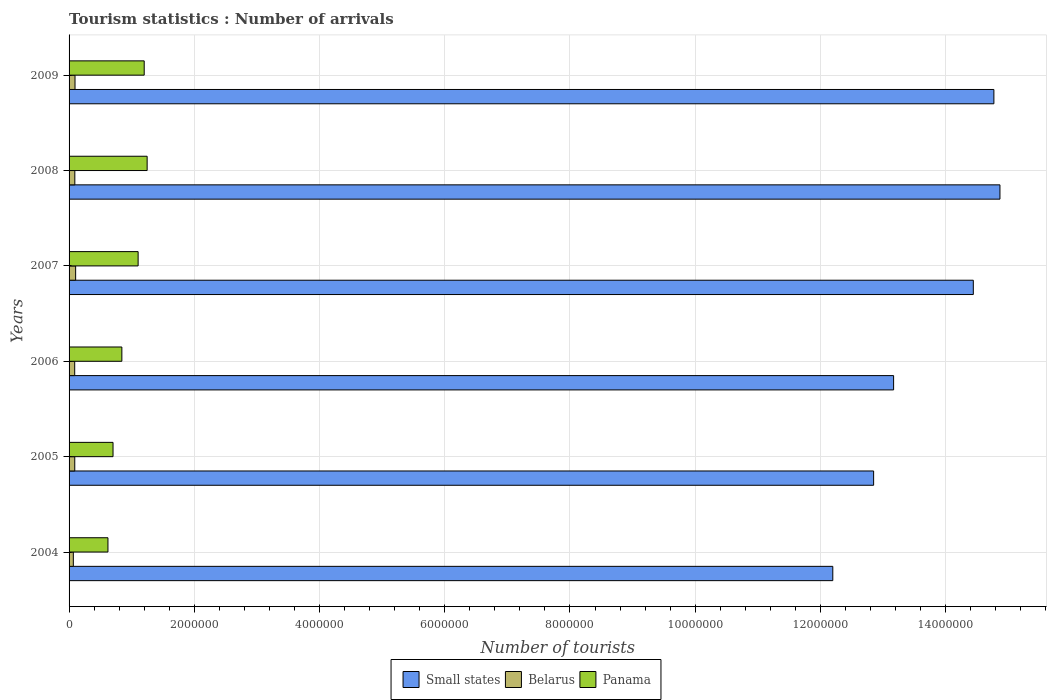What is the number of tourist arrivals in Belarus in 2006?
Your response must be concise. 9.00e+04. Across all years, what is the maximum number of tourist arrivals in Belarus?
Provide a succinct answer. 1.05e+05. Across all years, what is the minimum number of tourist arrivals in Belarus?
Offer a terse response. 6.80e+04. In which year was the number of tourist arrivals in Small states minimum?
Your answer should be very brief. 2004. What is the total number of tourist arrivals in Panama in the graph?
Ensure brevity in your answer.  5.72e+06. What is the difference between the number of tourist arrivals in Belarus in 2007 and that in 2008?
Keep it short and to the point. 1.30e+04. What is the difference between the number of tourist arrivals in Small states in 2005 and the number of tourist arrivals in Panama in 2009?
Ensure brevity in your answer.  1.16e+07. What is the average number of tourist arrivals in Belarus per year?
Provide a succinct answer. 9.02e+04. In the year 2005, what is the difference between the number of tourist arrivals in Belarus and number of tourist arrivals in Panama?
Make the answer very short. -6.11e+05. In how many years, is the number of tourist arrivals in Belarus greater than 11600000 ?
Provide a short and direct response. 0. What is the ratio of the number of tourist arrivals in Small states in 2006 to that in 2009?
Give a very brief answer. 0.89. What is the difference between the highest and the second highest number of tourist arrivals in Small states?
Make the answer very short. 9.68e+04. What is the difference between the highest and the lowest number of tourist arrivals in Belarus?
Ensure brevity in your answer.  3.70e+04. In how many years, is the number of tourist arrivals in Belarus greater than the average number of tourist arrivals in Belarus taken over all years?
Offer a very short reply. 4. Is the sum of the number of tourist arrivals in Panama in 2004 and 2007 greater than the maximum number of tourist arrivals in Belarus across all years?
Offer a very short reply. Yes. What does the 2nd bar from the top in 2009 represents?
Provide a short and direct response. Belarus. What does the 1st bar from the bottom in 2008 represents?
Give a very brief answer. Small states. Is it the case that in every year, the sum of the number of tourist arrivals in Belarus and number of tourist arrivals in Small states is greater than the number of tourist arrivals in Panama?
Provide a short and direct response. Yes. What is the difference between two consecutive major ticks on the X-axis?
Your answer should be compact. 2.00e+06. Are the values on the major ticks of X-axis written in scientific E-notation?
Keep it short and to the point. No. Where does the legend appear in the graph?
Your response must be concise. Bottom center. How many legend labels are there?
Provide a succinct answer. 3. What is the title of the graph?
Ensure brevity in your answer.  Tourism statistics : Number of arrivals. Does "Austria" appear as one of the legend labels in the graph?
Your answer should be very brief. No. What is the label or title of the X-axis?
Provide a succinct answer. Number of tourists. What is the Number of tourists in Small states in 2004?
Ensure brevity in your answer.  1.22e+07. What is the Number of tourists in Belarus in 2004?
Ensure brevity in your answer.  6.80e+04. What is the Number of tourists of Panama in 2004?
Make the answer very short. 6.21e+05. What is the Number of tourists of Small states in 2005?
Your answer should be compact. 1.28e+07. What is the Number of tourists of Belarus in 2005?
Offer a very short reply. 9.10e+04. What is the Number of tourists in Panama in 2005?
Your response must be concise. 7.02e+05. What is the Number of tourists of Small states in 2006?
Provide a short and direct response. 1.32e+07. What is the Number of tourists in Belarus in 2006?
Offer a terse response. 9.00e+04. What is the Number of tourists of Panama in 2006?
Make the answer very short. 8.43e+05. What is the Number of tourists of Small states in 2007?
Keep it short and to the point. 1.44e+07. What is the Number of tourists in Belarus in 2007?
Offer a terse response. 1.05e+05. What is the Number of tourists of Panama in 2007?
Give a very brief answer. 1.10e+06. What is the Number of tourists of Small states in 2008?
Offer a terse response. 1.49e+07. What is the Number of tourists of Belarus in 2008?
Offer a very short reply. 9.20e+04. What is the Number of tourists in Panama in 2008?
Ensure brevity in your answer.  1.25e+06. What is the Number of tourists of Small states in 2009?
Keep it short and to the point. 1.48e+07. What is the Number of tourists of Belarus in 2009?
Offer a terse response. 9.50e+04. What is the Number of tourists in Panama in 2009?
Offer a very short reply. 1.20e+06. Across all years, what is the maximum Number of tourists of Small states?
Give a very brief answer. 1.49e+07. Across all years, what is the maximum Number of tourists in Belarus?
Your response must be concise. 1.05e+05. Across all years, what is the maximum Number of tourists of Panama?
Your answer should be compact. 1.25e+06. Across all years, what is the minimum Number of tourists in Small states?
Provide a succinct answer. 1.22e+07. Across all years, what is the minimum Number of tourists of Belarus?
Make the answer very short. 6.80e+04. Across all years, what is the minimum Number of tourists of Panama?
Provide a succinct answer. 6.21e+05. What is the total Number of tourists in Small states in the graph?
Provide a short and direct response. 8.23e+07. What is the total Number of tourists of Belarus in the graph?
Ensure brevity in your answer.  5.41e+05. What is the total Number of tourists in Panama in the graph?
Your answer should be compact. 5.72e+06. What is the difference between the Number of tourists of Small states in 2004 and that in 2005?
Provide a short and direct response. -6.52e+05. What is the difference between the Number of tourists of Belarus in 2004 and that in 2005?
Make the answer very short. -2.30e+04. What is the difference between the Number of tourists of Panama in 2004 and that in 2005?
Make the answer very short. -8.10e+04. What is the difference between the Number of tourists of Small states in 2004 and that in 2006?
Give a very brief answer. -9.71e+05. What is the difference between the Number of tourists of Belarus in 2004 and that in 2006?
Keep it short and to the point. -2.20e+04. What is the difference between the Number of tourists in Panama in 2004 and that in 2006?
Your answer should be very brief. -2.22e+05. What is the difference between the Number of tourists of Small states in 2004 and that in 2007?
Provide a short and direct response. -2.24e+06. What is the difference between the Number of tourists of Belarus in 2004 and that in 2007?
Your answer should be compact. -3.70e+04. What is the difference between the Number of tourists of Panama in 2004 and that in 2007?
Offer a terse response. -4.82e+05. What is the difference between the Number of tourists in Small states in 2004 and that in 2008?
Your response must be concise. -2.67e+06. What is the difference between the Number of tourists in Belarus in 2004 and that in 2008?
Your response must be concise. -2.40e+04. What is the difference between the Number of tourists of Panama in 2004 and that in 2008?
Offer a very short reply. -6.26e+05. What is the difference between the Number of tourists of Small states in 2004 and that in 2009?
Provide a succinct answer. -2.57e+06. What is the difference between the Number of tourists of Belarus in 2004 and that in 2009?
Make the answer very short. -2.70e+04. What is the difference between the Number of tourists in Panama in 2004 and that in 2009?
Give a very brief answer. -5.79e+05. What is the difference between the Number of tourists of Small states in 2005 and that in 2006?
Keep it short and to the point. -3.19e+05. What is the difference between the Number of tourists of Belarus in 2005 and that in 2006?
Provide a short and direct response. 1000. What is the difference between the Number of tourists of Panama in 2005 and that in 2006?
Give a very brief answer. -1.41e+05. What is the difference between the Number of tourists in Small states in 2005 and that in 2007?
Provide a succinct answer. -1.59e+06. What is the difference between the Number of tourists in Belarus in 2005 and that in 2007?
Provide a succinct answer. -1.40e+04. What is the difference between the Number of tourists in Panama in 2005 and that in 2007?
Give a very brief answer. -4.01e+05. What is the difference between the Number of tourists of Small states in 2005 and that in 2008?
Offer a terse response. -2.02e+06. What is the difference between the Number of tourists in Belarus in 2005 and that in 2008?
Give a very brief answer. -1000. What is the difference between the Number of tourists in Panama in 2005 and that in 2008?
Your answer should be very brief. -5.45e+05. What is the difference between the Number of tourists of Small states in 2005 and that in 2009?
Make the answer very short. -1.92e+06. What is the difference between the Number of tourists of Belarus in 2005 and that in 2009?
Make the answer very short. -4000. What is the difference between the Number of tourists in Panama in 2005 and that in 2009?
Your response must be concise. -4.98e+05. What is the difference between the Number of tourists of Small states in 2006 and that in 2007?
Give a very brief answer. -1.27e+06. What is the difference between the Number of tourists of Belarus in 2006 and that in 2007?
Provide a short and direct response. -1.50e+04. What is the difference between the Number of tourists in Small states in 2006 and that in 2008?
Provide a succinct answer. -1.70e+06. What is the difference between the Number of tourists of Belarus in 2006 and that in 2008?
Make the answer very short. -2000. What is the difference between the Number of tourists in Panama in 2006 and that in 2008?
Your answer should be compact. -4.04e+05. What is the difference between the Number of tourists of Small states in 2006 and that in 2009?
Offer a terse response. -1.60e+06. What is the difference between the Number of tourists of Belarus in 2006 and that in 2009?
Make the answer very short. -5000. What is the difference between the Number of tourists of Panama in 2006 and that in 2009?
Ensure brevity in your answer.  -3.57e+05. What is the difference between the Number of tourists of Small states in 2007 and that in 2008?
Provide a short and direct response. -4.25e+05. What is the difference between the Number of tourists of Belarus in 2007 and that in 2008?
Give a very brief answer. 1.30e+04. What is the difference between the Number of tourists in Panama in 2007 and that in 2008?
Offer a very short reply. -1.44e+05. What is the difference between the Number of tourists in Small states in 2007 and that in 2009?
Make the answer very short. -3.28e+05. What is the difference between the Number of tourists in Panama in 2007 and that in 2009?
Offer a very short reply. -9.70e+04. What is the difference between the Number of tourists of Small states in 2008 and that in 2009?
Your answer should be very brief. 9.68e+04. What is the difference between the Number of tourists of Belarus in 2008 and that in 2009?
Ensure brevity in your answer.  -3000. What is the difference between the Number of tourists of Panama in 2008 and that in 2009?
Give a very brief answer. 4.70e+04. What is the difference between the Number of tourists in Small states in 2004 and the Number of tourists in Belarus in 2005?
Give a very brief answer. 1.21e+07. What is the difference between the Number of tourists of Small states in 2004 and the Number of tourists of Panama in 2005?
Provide a short and direct response. 1.15e+07. What is the difference between the Number of tourists of Belarus in 2004 and the Number of tourists of Panama in 2005?
Offer a terse response. -6.34e+05. What is the difference between the Number of tourists of Small states in 2004 and the Number of tourists of Belarus in 2006?
Provide a succinct answer. 1.21e+07. What is the difference between the Number of tourists in Small states in 2004 and the Number of tourists in Panama in 2006?
Provide a succinct answer. 1.14e+07. What is the difference between the Number of tourists in Belarus in 2004 and the Number of tourists in Panama in 2006?
Give a very brief answer. -7.75e+05. What is the difference between the Number of tourists of Small states in 2004 and the Number of tourists of Belarus in 2007?
Your answer should be compact. 1.21e+07. What is the difference between the Number of tourists in Small states in 2004 and the Number of tourists in Panama in 2007?
Your response must be concise. 1.11e+07. What is the difference between the Number of tourists of Belarus in 2004 and the Number of tourists of Panama in 2007?
Your response must be concise. -1.04e+06. What is the difference between the Number of tourists in Small states in 2004 and the Number of tourists in Belarus in 2008?
Provide a succinct answer. 1.21e+07. What is the difference between the Number of tourists of Small states in 2004 and the Number of tourists of Panama in 2008?
Your answer should be very brief. 1.10e+07. What is the difference between the Number of tourists of Belarus in 2004 and the Number of tourists of Panama in 2008?
Ensure brevity in your answer.  -1.18e+06. What is the difference between the Number of tourists in Small states in 2004 and the Number of tourists in Belarus in 2009?
Make the answer very short. 1.21e+07. What is the difference between the Number of tourists of Small states in 2004 and the Number of tourists of Panama in 2009?
Offer a terse response. 1.10e+07. What is the difference between the Number of tourists in Belarus in 2004 and the Number of tourists in Panama in 2009?
Keep it short and to the point. -1.13e+06. What is the difference between the Number of tourists in Small states in 2005 and the Number of tourists in Belarus in 2006?
Your answer should be compact. 1.28e+07. What is the difference between the Number of tourists of Small states in 2005 and the Number of tourists of Panama in 2006?
Your answer should be compact. 1.20e+07. What is the difference between the Number of tourists of Belarus in 2005 and the Number of tourists of Panama in 2006?
Your response must be concise. -7.52e+05. What is the difference between the Number of tourists of Small states in 2005 and the Number of tourists of Belarus in 2007?
Offer a terse response. 1.27e+07. What is the difference between the Number of tourists in Small states in 2005 and the Number of tourists in Panama in 2007?
Your answer should be very brief. 1.17e+07. What is the difference between the Number of tourists in Belarus in 2005 and the Number of tourists in Panama in 2007?
Offer a terse response. -1.01e+06. What is the difference between the Number of tourists in Small states in 2005 and the Number of tourists in Belarus in 2008?
Your response must be concise. 1.28e+07. What is the difference between the Number of tourists of Small states in 2005 and the Number of tourists of Panama in 2008?
Offer a terse response. 1.16e+07. What is the difference between the Number of tourists of Belarus in 2005 and the Number of tourists of Panama in 2008?
Provide a short and direct response. -1.16e+06. What is the difference between the Number of tourists of Small states in 2005 and the Number of tourists of Belarus in 2009?
Offer a terse response. 1.28e+07. What is the difference between the Number of tourists of Small states in 2005 and the Number of tourists of Panama in 2009?
Offer a very short reply. 1.16e+07. What is the difference between the Number of tourists of Belarus in 2005 and the Number of tourists of Panama in 2009?
Your answer should be compact. -1.11e+06. What is the difference between the Number of tourists of Small states in 2006 and the Number of tourists of Belarus in 2007?
Your answer should be very brief. 1.31e+07. What is the difference between the Number of tourists of Small states in 2006 and the Number of tourists of Panama in 2007?
Keep it short and to the point. 1.21e+07. What is the difference between the Number of tourists in Belarus in 2006 and the Number of tourists in Panama in 2007?
Provide a short and direct response. -1.01e+06. What is the difference between the Number of tourists in Small states in 2006 and the Number of tourists in Belarus in 2008?
Your response must be concise. 1.31e+07. What is the difference between the Number of tourists in Small states in 2006 and the Number of tourists in Panama in 2008?
Offer a very short reply. 1.19e+07. What is the difference between the Number of tourists in Belarus in 2006 and the Number of tourists in Panama in 2008?
Your response must be concise. -1.16e+06. What is the difference between the Number of tourists in Small states in 2006 and the Number of tourists in Belarus in 2009?
Your response must be concise. 1.31e+07. What is the difference between the Number of tourists of Small states in 2006 and the Number of tourists of Panama in 2009?
Provide a succinct answer. 1.20e+07. What is the difference between the Number of tourists of Belarus in 2006 and the Number of tourists of Panama in 2009?
Offer a terse response. -1.11e+06. What is the difference between the Number of tourists in Small states in 2007 and the Number of tourists in Belarus in 2008?
Provide a succinct answer. 1.44e+07. What is the difference between the Number of tourists of Small states in 2007 and the Number of tourists of Panama in 2008?
Provide a succinct answer. 1.32e+07. What is the difference between the Number of tourists in Belarus in 2007 and the Number of tourists in Panama in 2008?
Offer a terse response. -1.14e+06. What is the difference between the Number of tourists of Small states in 2007 and the Number of tourists of Belarus in 2009?
Your response must be concise. 1.43e+07. What is the difference between the Number of tourists in Small states in 2007 and the Number of tourists in Panama in 2009?
Offer a very short reply. 1.32e+07. What is the difference between the Number of tourists of Belarus in 2007 and the Number of tourists of Panama in 2009?
Provide a succinct answer. -1.10e+06. What is the difference between the Number of tourists in Small states in 2008 and the Number of tourists in Belarus in 2009?
Keep it short and to the point. 1.48e+07. What is the difference between the Number of tourists of Small states in 2008 and the Number of tourists of Panama in 2009?
Offer a very short reply. 1.37e+07. What is the difference between the Number of tourists in Belarus in 2008 and the Number of tourists in Panama in 2009?
Ensure brevity in your answer.  -1.11e+06. What is the average Number of tourists of Small states per year?
Keep it short and to the point. 1.37e+07. What is the average Number of tourists in Belarus per year?
Keep it short and to the point. 9.02e+04. What is the average Number of tourists in Panama per year?
Ensure brevity in your answer.  9.53e+05. In the year 2004, what is the difference between the Number of tourists in Small states and Number of tourists in Belarus?
Offer a very short reply. 1.21e+07. In the year 2004, what is the difference between the Number of tourists of Small states and Number of tourists of Panama?
Your answer should be compact. 1.16e+07. In the year 2004, what is the difference between the Number of tourists in Belarus and Number of tourists in Panama?
Your response must be concise. -5.53e+05. In the year 2005, what is the difference between the Number of tourists in Small states and Number of tourists in Belarus?
Provide a succinct answer. 1.28e+07. In the year 2005, what is the difference between the Number of tourists in Small states and Number of tourists in Panama?
Your response must be concise. 1.21e+07. In the year 2005, what is the difference between the Number of tourists in Belarus and Number of tourists in Panama?
Your answer should be very brief. -6.11e+05. In the year 2006, what is the difference between the Number of tourists in Small states and Number of tourists in Belarus?
Provide a succinct answer. 1.31e+07. In the year 2006, what is the difference between the Number of tourists in Small states and Number of tourists in Panama?
Make the answer very short. 1.23e+07. In the year 2006, what is the difference between the Number of tourists in Belarus and Number of tourists in Panama?
Keep it short and to the point. -7.53e+05. In the year 2007, what is the difference between the Number of tourists of Small states and Number of tourists of Belarus?
Offer a terse response. 1.43e+07. In the year 2007, what is the difference between the Number of tourists of Small states and Number of tourists of Panama?
Make the answer very short. 1.33e+07. In the year 2007, what is the difference between the Number of tourists in Belarus and Number of tourists in Panama?
Offer a terse response. -9.98e+05. In the year 2008, what is the difference between the Number of tourists of Small states and Number of tourists of Belarus?
Provide a short and direct response. 1.48e+07. In the year 2008, what is the difference between the Number of tourists in Small states and Number of tourists in Panama?
Provide a succinct answer. 1.36e+07. In the year 2008, what is the difference between the Number of tourists of Belarus and Number of tourists of Panama?
Give a very brief answer. -1.16e+06. In the year 2009, what is the difference between the Number of tourists in Small states and Number of tourists in Belarus?
Make the answer very short. 1.47e+07. In the year 2009, what is the difference between the Number of tourists of Small states and Number of tourists of Panama?
Keep it short and to the point. 1.36e+07. In the year 2009, what is the difference between the Number of tourists of Belarus and Number of tourists of Panama?
Ensure brevity in your answer.  -1.10e+06. What is the ratio of the Number of tourists of Small states in 2004 to that in 2005?
Make the answer very short. 0.95. What is the ratio of the Number of tourists of Belarus in 2004 to that in 2005?
Your answer should be very brief. 0.75. What is the ratio of the Number of tourists of Panama in 2004 to that in 2005?
Provide a succinct answer. 0.88. What is the ratio of the Number of tourists of Small states in 2004 to that in 2006?
Give a very brief answer. 0.93. What is the ratio of the Number of tourists in Belarus in 2004 to that in 2006?
Your answer should be compact. 0.76. What is the ratio of the Number of tourists in Panama in 2004 to that in 2006?
Offer a very short reply. 0.74. What is the ratio of the Number of tourists in Small states in 2004 to that in 2007?
Your answer should be very brief. 0.84. What is the ratio of the Number of tourists of Belarus in 2004 to that in 2007?
Ensure brevity in your answer.  0.65. What is the ratio of the Number of tourists of Panama in 2004 to that in 2007?
Make the answer very short. 0.56. What is the ratio of the Number of tourists in Small states in 2004 to that in 2008?
Offer a very short reply. 0.82. What is the ratio of the Number of tourists of Belarus in 2004 to that in 2008?
Make the answer very short. 0.74. What is the ratio of the Number of tourists in Panama in 2004 to that in 2008?
Offer a very short reply. 0.5. What is the ratio of the Number of tourists of Small states in 2004 to that in 2009?
Offer a terse response. 0.83. What is the ratio of the Number of tourists of Belarus in 2004 to that in 2009?
Offer a very short reply. 0.72. What is the ratio of the Number of tourists in Panama in 2004 to that in 2009?
Offer a terse response. 0.52. What is the ratio of the Number of tourists in Small states in 2005 to that in 2006?
Your answer should be compact. 0.98. What is the ratio of the Number of tourists of Belarus in 2005 to that in 2006?
Your answer should be very brief. 1.01. What is the ratio of the Number of tourists in Panama in 2005 to that in 2006?
Your answer should be compact. 0.83. What is the ratio of the Number of tourists of Small states in 2005 to that in 2007?
Make the answer very short. 0.89. What is the ratio of the Number of tourists of Belarus in 2005 to that in 2007?
Ensure brevity in your answer.  0.87. What is the ratio of the Number of tourists of Panama in 2005 to that in 2007?
Offer a terse response. 0.64. What is the ratio of the Number of tourists of Small states in 2005 to that in 2008?
Provide a succinct answer. 0.86. What is the ratio of the Number of tourists of Belarus in 2005 to that in 2008?
Provide a short and direct response. 0.99. What is the ratio of the Number of tourists in Panama in 2005 to that in 2008?
Ensure brevity in your answer.  0.56. What is the ratio of the Number of tourists of Small states in 2005 to that in 2009?
Give a very brief answer. 0.87. What is the ratio of the Number of tourists of Belarus in 2005 to that in 2009?
Your response must be concise. 0.96. What is the ratio of the Number of tourists in Panama in 2005 to that in 2009?
Give a very brief answer. 0.58. What is the ratio of the Number of tourists in Small states in 2006 to that in 2007?
Your response must be concise. 0.91. What is the ratio of the Number of tourists in Panama in 2006 to that in 2007?
Keep it short and to the point. 0.76. What is the ratio of the Number of tourists of Small states in 2006 to that in 2008?
Ensure brevity in your answer.  0.89. What is the ratio of the Number of tourists of Belarus in 2006 to that in 2008?
Make the answer very short. 0.98. What is the ratio of the Number of tourists in Panama in 2006 to that in 2008?
Provide a short and direct response. 0.68. What is the ratio of the Number of tourists of Small states in 2006 to that in 2009?
Offer a terse response. 0.89. What is the ratio of the Number of tourists of Panama in 2006 to that in 2009?
Your answer should be very brief. 0.7. What is the ratio of the Number of tourists of Small states in 2007 to that in 2008?
Keep it short and to the point. 0.97. What is the ratio of the Number of tourists in Belarus in 2007 to that in 2008?
Give a very brief answer. 1.14. What is the ratio of the Number of tourists in Panama in 2007 to that in 2008?
Make the answer very short. 0.88. What is the ratio of the Number of tourists of Small states in 2007 to that in 2009?
Offer a terse response. 0.98. What is the ratio of the Number of tourists of Belarus in 2007 to that in 2009?
Offer a terse response. 1.11. What is the ratio of the Number of tourists of Panama in 2007 to that in 2009?
Offer a terse response. 0.92. What is the ratio of the Number of tourists of Small states in 2008 to that in 2009?
Offer a very short reply. 1.01. What is the ratio of the Number of tourists in Belarus in 2008 to that in 2009?
Give a very brief answer. 0.97. What is the ratio of the Number of tourists in Panama in 2008 to that in 2009?
Your answer should be very brief. 1.04. What is the difference between the highest and the second highest Number of tourists in Small states?
Your answer should be compact. 9.68e+04. What is the difference between the highest and the second highest Number of tourists in Panama?
Your answer should be very brief. 4.70e+04. What is the difference between the highest and the lowest Number of tourists in Small states?
Your answer should be compact. 2.67e+06. What is the difference between the highest and the lowest Number of tourists of Belarus?
Provide a succinct answer. 3.70e+04. What is the difference between the highest and the lowest Number of tourists of Panama?
Give a very brief answer. 6.26e+05. 